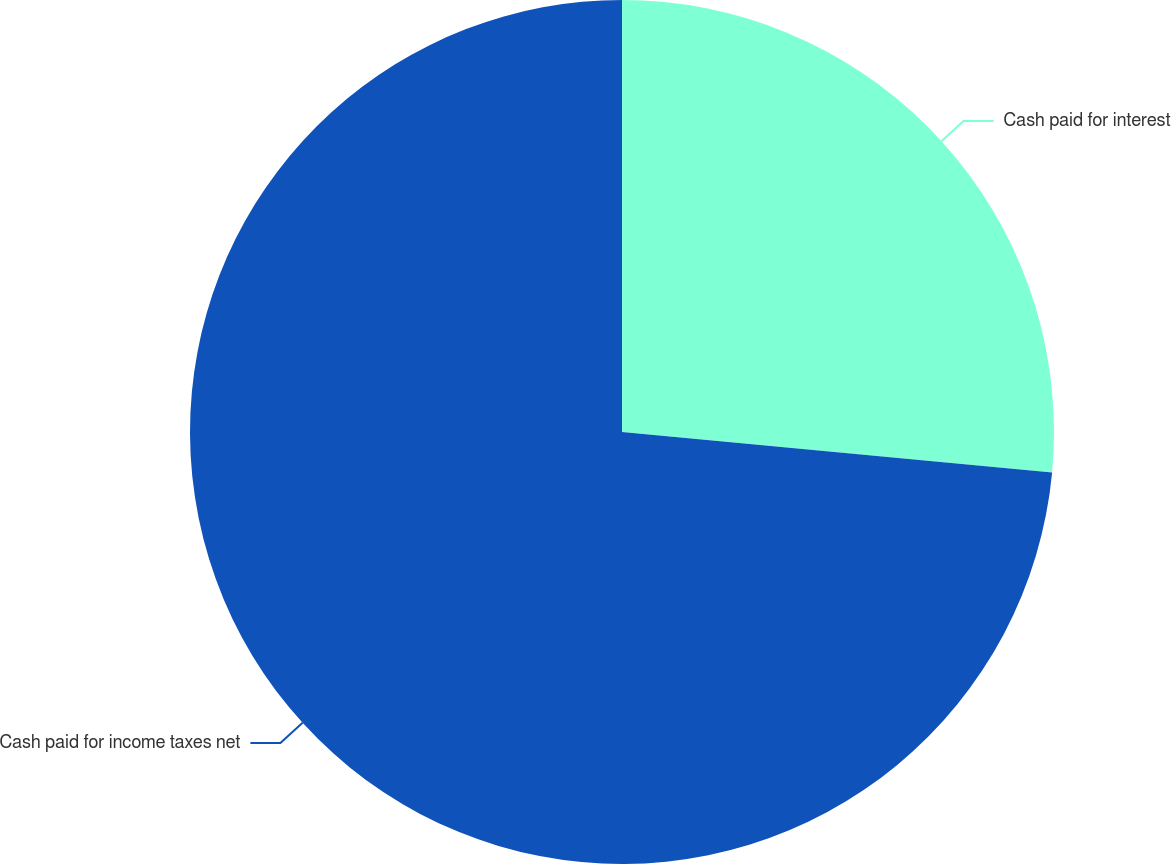<chart> <loc_0><loc_0><loc_500><loc_500><pie_chart><fcel>Cash paid for interest<fcel>Cash paid for income taxes net<nl><fcel>26.49%<fcel>73.51%<nl></chart> 